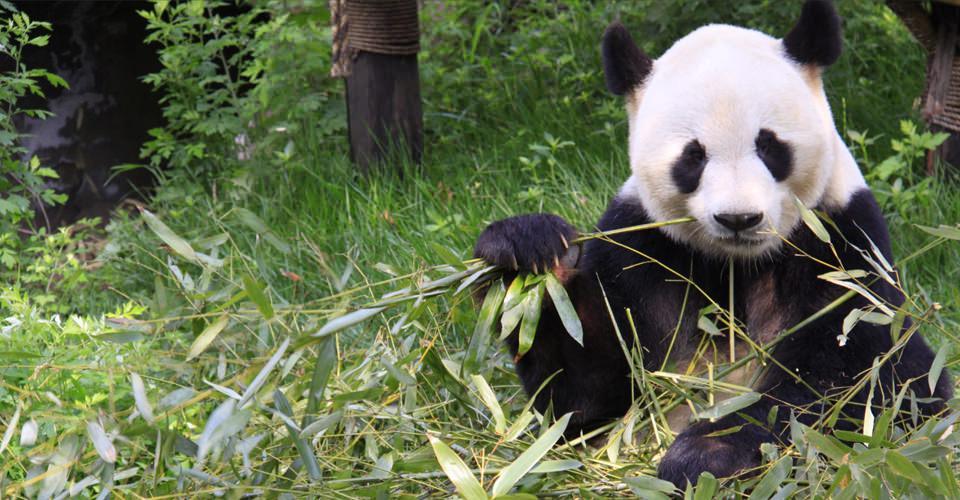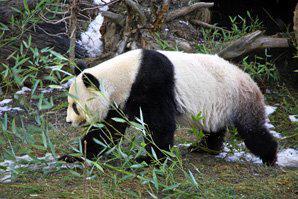The first image is the image on the left, the second image is the image on the right. Examine the images to the left and right. Is the description "A panda is climbing a wooden limb in one image, and pandas are munching on bamboo leaves in the other image." accurate? Answer yes or no. No. The first image is the image on the left, the second image is the image on the right. Considering the images on both sides, is "The left image contains exactly one panda." valid? Answer yes or no. Yes. 